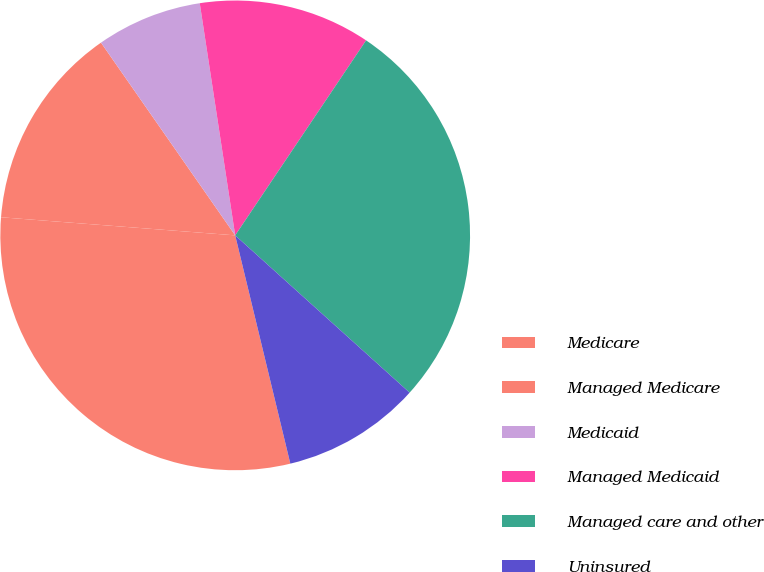<chart> <loc_0><loc_0><loc_500><loc_500><pie_chart><fcel>Medicare<fcel>Managed Medicare<fcel>Medicaid<fcel>Managed Medicaid<fcel>Managed care and other<fcel>Uninsured<nl><fcel>30.0%<fcel>14.09%<fcel>7.27%<fcel>11.82%<fcel>27.27%<fcel>9.55%<nl></chart> 